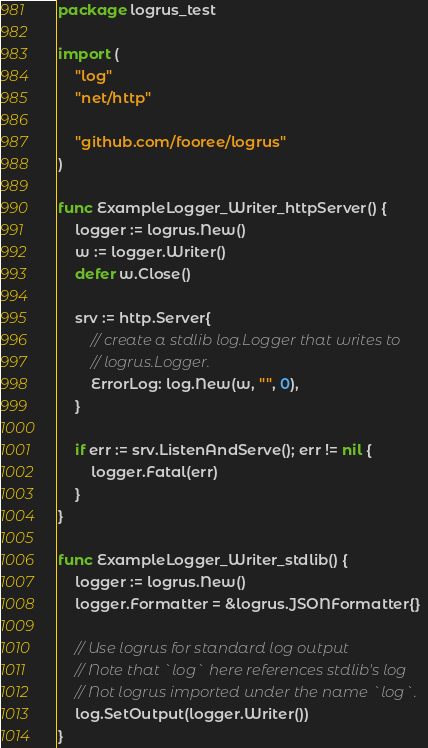<code> <loc_0><loc_0><loc_500><loc_500><_Go_>package logrus_test

import (
	"log"
	"net/http"

	"github.com/fooree/logrus"
)

func ExampleLogger_Writer_httpServer() {
	logger := logrus.New()
	w := logger.Writer()
	defer w.Close()

	srv := http.Server{
		// create a stdlib log.Logger that writes to
		// logrus.Logger.
		ErrorLog: log.New(w, "", 0),
	}

	if err := srv.ListenAndServe(); err != nil {
		logger.Fatal(err)
	}
}

func ExampleLogger_Writer_stdlib() {
	logger := logrus.New()
	logger.Formatter = &logrus.JSONFormatter{}

	// Use logrus for standard log output
	// Note that `log` here references stdlib's log
	// Not logrus imported under the name `log`.
	log.SetOutput(logger.Writer())
}
</code> 